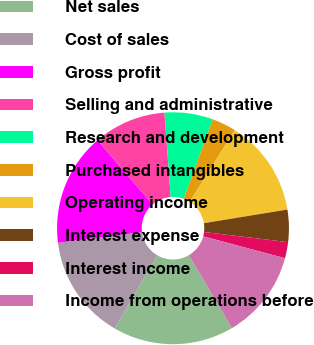<chart> <loc_0><loc_0><loc_500><loc_500><pie_chart><fcel>Net sales<fcel>Cost of sales<fcel>Gross profit<fcel>Selling and administrative<fcel>Research and development<fcel>Purchased intangibles<fcel>Operating income<fcel>Interest expense<fcel>Interest income<fcel>Income from operations before<nl><fcel>16.85%<fcel>14.61%<fcel>15.73%<fcel>10.11%<fcel>6.74%<fcel>3.37%<fcel>13.48%<fcel>4.49%<fcel>2.25%<fcel>12.36%<nl></chart> 